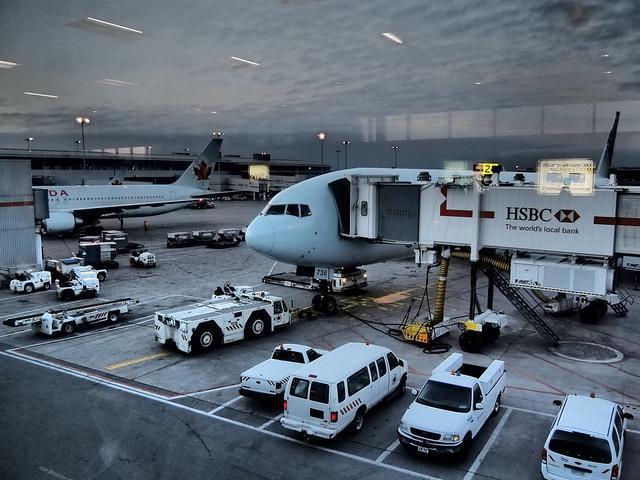How many planes can be seen?
Give a very brief answer. 2. How many trucks can you see?
Give a very brief answer. 5. How many cars are there?
Give a very brief answer. 2. How many airplanes are in the picture?
Give a very brief answer. 2. 